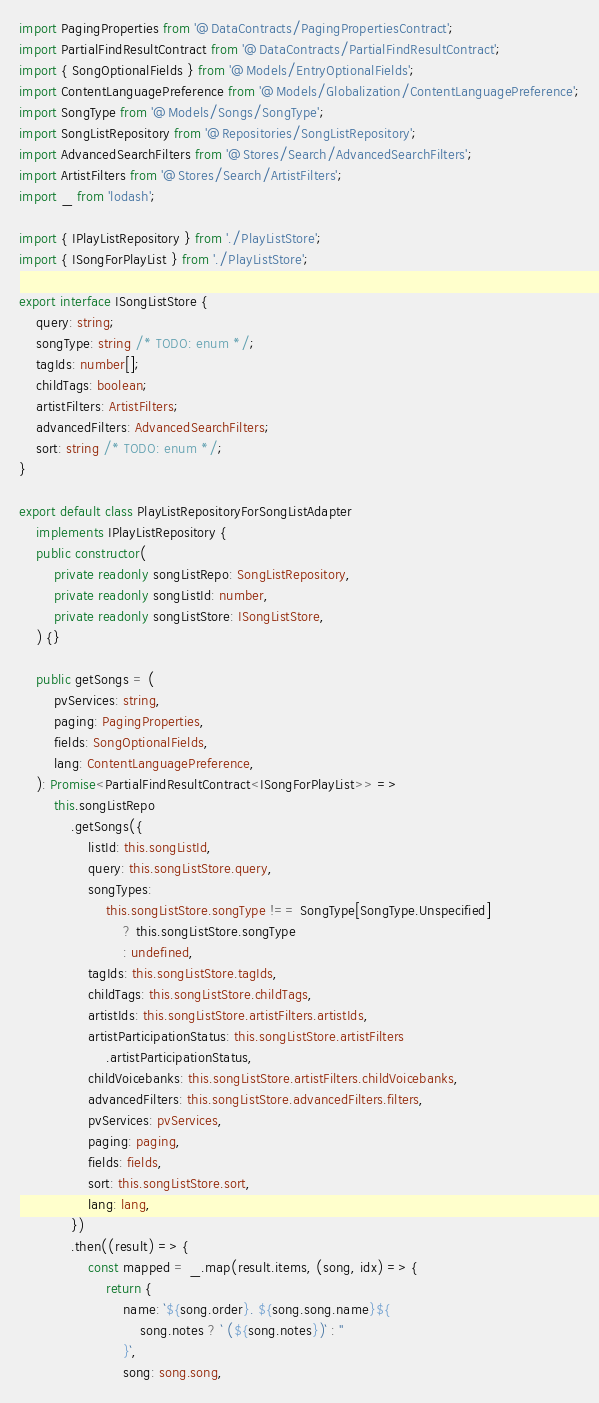Convert code to text. <code><loc_0><loc_0><loc_500><loc_500><_TypeScript_>import PagingProperties from '@DataContracts/PagingPropertiesContract';
import PartialFindResultContract from '@DataContracts/PartialFindResultContract';
import { SongOptionalFields } from '@Models/EntryOptionalFields';
import ContentLanguagePreference from '@Models/Globalization/ContentLanguagePreference';
import SongType from '@Models/Songs/SongType';
import SongListRepository from '@Repositories/SongListRepository';
import AdvancedSearchFilters from '@Stores/Search/AdvancedSearchFilters';
import ArtistFilters from '@Stores/Search/ArtistFilters';
import _ from 'lodash';

import { IPlayListRepository } from './PlayListStore';
import { ISongForPlayList } from './PlayListStore';

export interface ISongListStore {
	query: string;
	songType: string /* TODO: enum */;
	tagIds: number[];
	childTags: boolean;
	artistFilters: ArtistFilters;
	advancedFilters: AdvancedSearchFilters;
	sort: string /* TODO: enum */;
}

export default class PlayListRepositoryForSongListAdapter
	implements IPlayListRepository {
	public constructor(
		private readonly songListRepo: SongListRepository,
		private readonly songListId: number,
		private readonly songListStore: ISongListStore,
	) {}

	public getSongs = (
		pvServices: string,
		paging: PagingProperties,
		fields: SongOptionalFields,
		lang: ContentLanguagePreference,
	): Promise<PartialFindResultContract<ISongForPlayList>> =>
		this.songListRepo
			.getSongs({
				listId: this.songListId,
				query: this.songListStore.query,
				songTypes:
					this.songListStore.songType !== SongType[SongType.Unspecified]
						? this.songListStore.songType
						: undefined,
				tagIds: this.songListStore.tagIds,
				childTags: this.songListStore.childTags,
				artistIds: this.songListStore.artistFilters.artistIds,
				artistParticipationStatus: this.songListStore.artistFilters
					.artistParticipationStatus,
				childVoicebanks: this.songListStore.artistFilters.childVoicebanks,
				advancedFilters: this.songListStore.advancedFilters.filters,
				pvServices: pvServices,
				paging: paging,
				fields: fields,
				sort: this.songListStore.sort,
				lang: lang,
			})
			.then((result) => {
				const mapped = _.map(result.items, (song, idx) => {
					return {
						name: `${song.order}. ${song.song.name}${
							song.notes ? ` (${song.notes})` : ''
						}`,
						song: song.song,</code> 